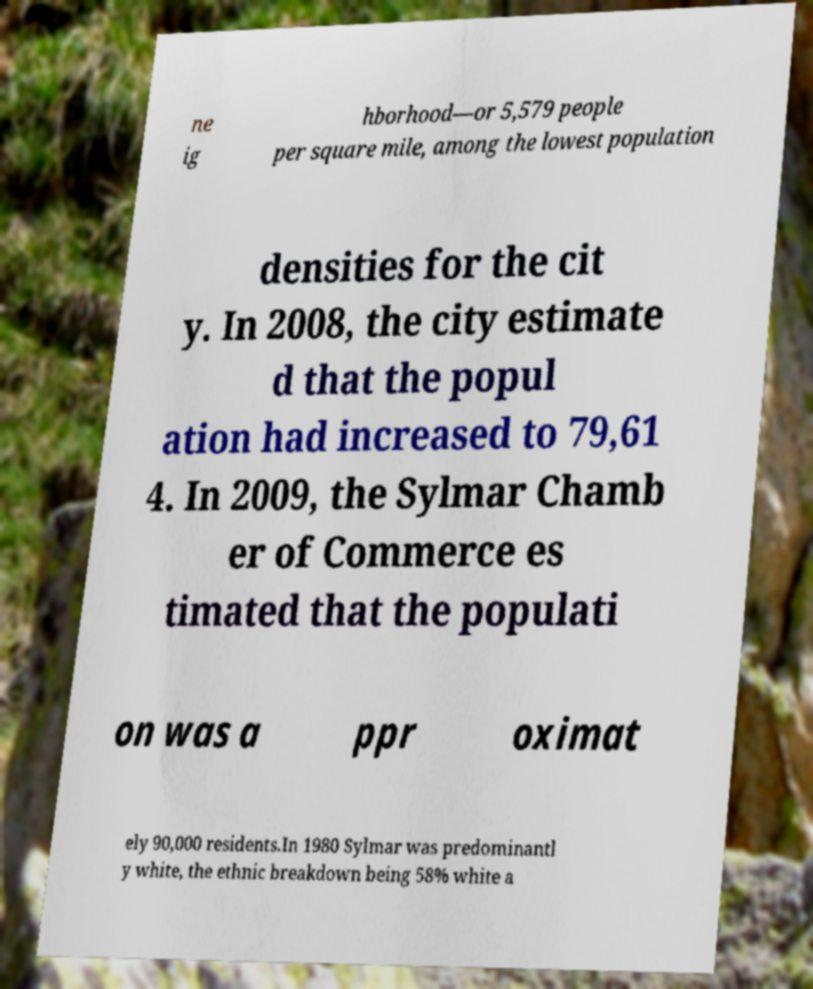Could you assist in decoding the text presented in this image and type it out clearly? ne ig hborhood—or 5,579 people per square mile, among the lowest population densities for the cit y. In 2008, the city estimate d that the popul ation had increased to 79,61 4. In 2009, the Sylmar Chamb er of Commerce es timated that the populati on was a ppr oximat ely 90,000 residents.In 1980 Sylmar was predominantl y white, the ethnic breakdown being 58% white a 